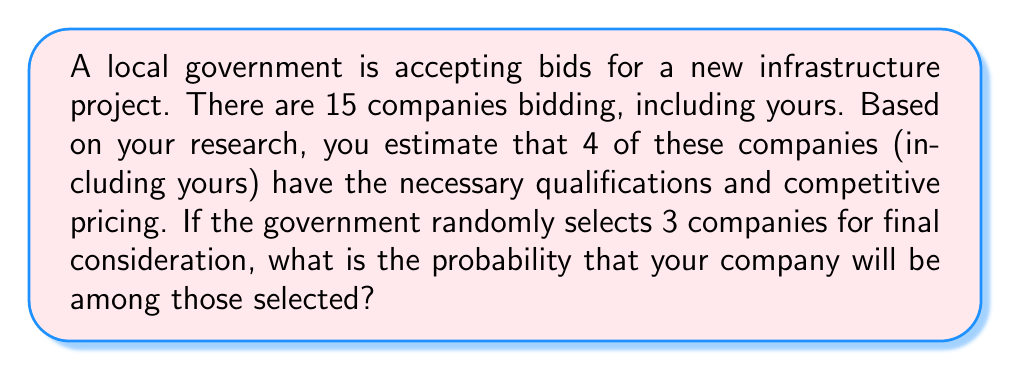Can you solve this math problem? Let's approach this step-by-step using combinatorics:

1) First, we need to calculate the total number of ways 3 companies can be selected from 15. This is given by the combination formula:

   $$\binom{15}{3} = \frac{15!}{3!(15-3)!} = \frac{15!}{3!12!} = 455$$

2) Now, we need to calculate the number of favorable outcomes. These are the selections that include your company. Since your company must be included, we only need to choose 2 more companies from the remaining 14. This is given by:

   $$\binom{14}{2} = \frac{14!}{2!(14-2)!} = \frac{14!}{2!12!} = 91$$

3) The probability is then the number of favorable outcomes divided by the total number of possible outcomes:

   $$P(\text{Your company selected}) = \frac{\text{Favorable outcomes}}{\text{Total outcomes}} = \frac{91}{455}$$

4) This fraction can be reduced:

   $$\frac{91}{455} = \frac{1}{5} = 0.2$$

Therefore, the probability of your company being selected is $\frac{1}{5}$ or 0.2 or 20%.
Answer: $\frac{1}{5}$ 